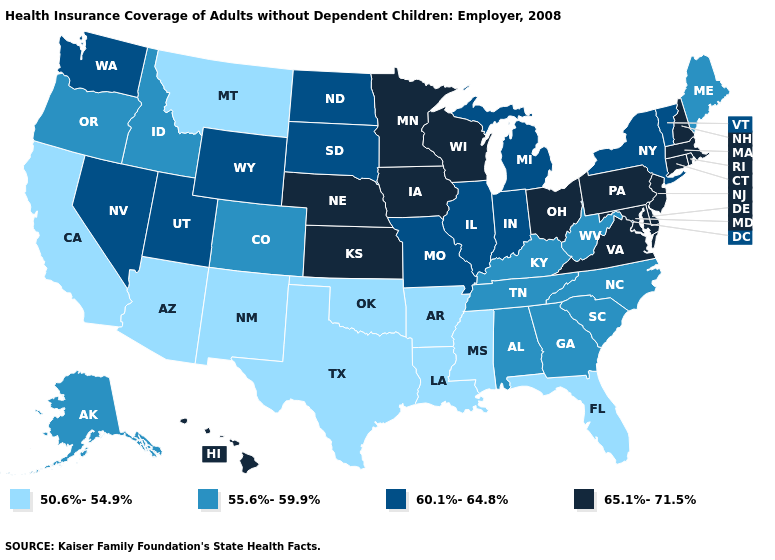What is the value of Alabama?
Short answer required. 55.6%-59.9%. What is the value of North Carolina?
Answer briefly. 55.6%-59.9%. What is the value of New Hampshire?
Quick response, please. 65.1%-71.5%. Which states have the highest value in the USA?
Write a very short answer. Connecticut, Delaware, Hawaii, Iowa, Kansas, Maryland, Massachusetts, Minnesota, Nebraska, New Hampshire, New Jersey, Ohio, Pennsylvania, Rhode Island, Virginia, Wisconsin. What is the value of New Hampshire?
Concise answer only. 65.1%-71.5%. Does Connecticut have the lowest value in the Northeast?
Keep it brief. No. Name the states that have a value in the range 55.6%-59.9%?
Keep it brief. Alabama, Alaska, Colorado, Georgia, Idaho, Kentucky, Maine, North Carolina, Oregon, South Carolina, Tennessee, West Virginia. Name the states that have a value in the range 60.1%-64.8%?
Keep it brief. Illinois, Indiana, Michigan, Missouri, Nevada, New York, North Dakota, South Dakota, Utah, Vermont, Washington, Wyoming. What is the highest value in the South ?
Short answer required. 65.1%-71.5%. Does the first symbol in the legend represent the smallest category?
Short answer required. Yes. Among the states that border Minnesota , does Wisconsin have the highest value?
Short answer required. Yes. What is the lowest value in states that border Massachusetts?
Be succinct. 60.1%-64.8%. Does Washington have the lowest value in the West?
Give a very brief answer. No. Does Nebraska have the highest value in the USA?
Write a very short answer. Yes. Name the states that have a value in the range 65.1%-71.5%?
Concise answer only. Connecticut, Delaware, Hawaii, Iowa, Kansas, Maryland, Massachusetts, Minnesota, Nebraska, New Hampshire, New Jersey, Ohio, Pennsylvania, Rhode Island, Virginia, Wisconsin. 